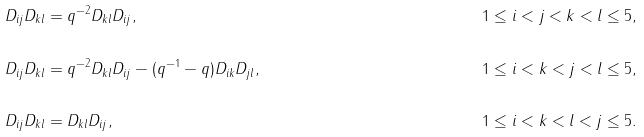Convert formula to latex. <formula><loc_0><loc_0><loc_500><loc_500>& D _ { i j } D _ { k l } = q ^ { - 2 } D _ { k l } D _ { i j } , & & 1 \leq i < j < k < l \leq 5 , \\ \\ & D _ { i j } D _ { k l } = q ^ { - 2 } D _ { k l } D _ { i j } - ( q ^ { - 1 } - q ) D _ { i k } D _ { j l } , & & 1 \leq i < k < j < l \leq 5 , \\ \\ & D _ { i j } D _ { k l } = D _ { k l } D _ { i j } , & & 1 \leq i < k < l < j \leq 5 .</formula> 